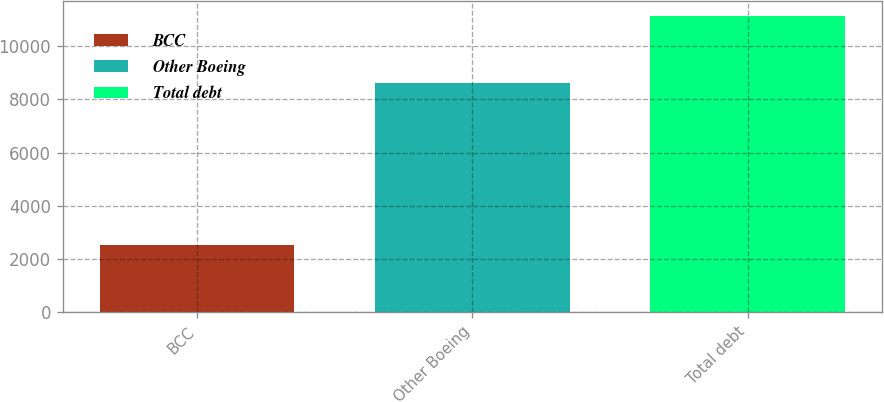Convert chart to OTSL. <chart><loc_0><loc_0><loc_500><loc_500><bar_chart><fcel>BCC<fcel>Other Boeing<fcel>Total debt<nl><fcel>2523<fcel>8594<fcel>11117<nl></chart> 